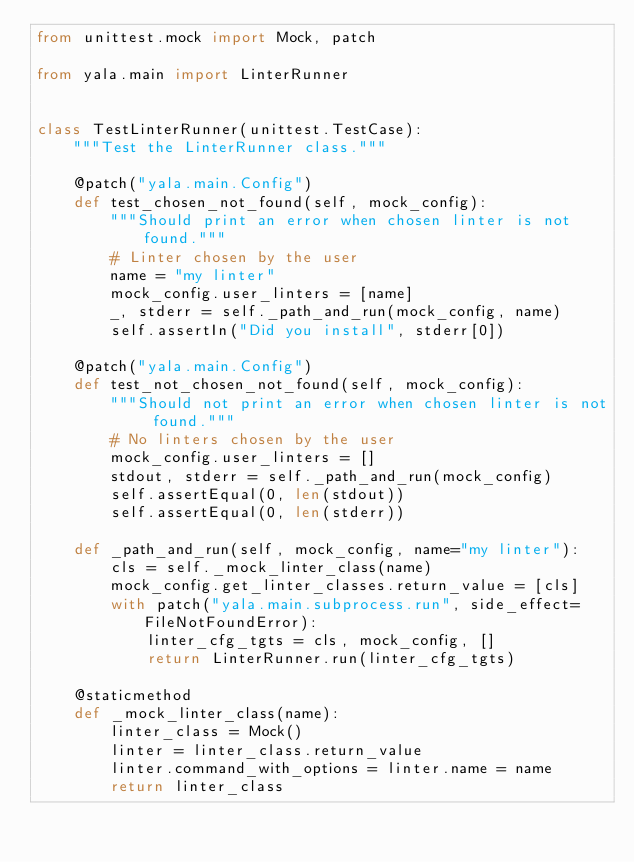Convert code to text. <code><loc_0><loc_0><loc_500><loc_500><_Python_>from unittest.mock import Mock, patch

from yala.main import LinterRunner


class TestLinterRunner(unittest.TestCase):
    """Test the LinterRunner class."""

    @patch("yala.main.Config")
    def test_chosen_not_found(self, mock_config):
        """Should print an error when chosen linter is not found."""
        # Linter chosen by the user
        name = "my linter"
        mock_config.user_linters = [name]
        _, stderr = self._path_and_run(mock_config, name)
        self.assertIn("Did you install", stderr[0])

    @patch("yala.main.Config")
    def test_not_chosen_not_found(self, mock_config):
        """Should not print an error when chosen linter is not found."""
        # No linters chosen by the user
        mock_config.user_linters = []
        stdout, stderr = self._path_and_run(mock_config)
        self.assertEqual(0, len(stdout))
        self.assertEqual(0, len(stderr))

    def _path_and_run(self, mock_config, name="my linter"):
        cls = self._mock_linter_class(name)
        mock_config.get_linter_classes.return_value = [cls]
        with patch("yala.main.subprocess.run", side_effect=FileNotFoundError):
            linter_cfg_tgts = cls, mock_config, []
            return LinterRunner.run(linter_cfg_tgts)

    @staticmethod
    def _mock_linter_class(name):
        linter_class = Mock()
        linter = linter_class.return_value
        linter.command_with_options = linter.name = name
        return linter_class
</code> 